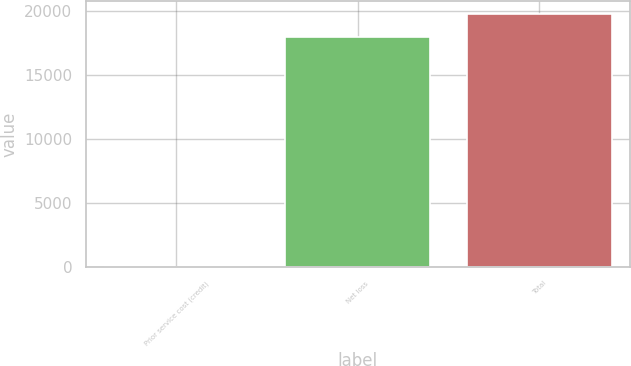Convert chart to OTSL. <chart><loc_0><loc_0><loc_500><loc_500><bar_chart><fcel>Prior service cost (credit)<fcel>Net loss<fcel>Total<nl><fcel>18<fcel>17986<fcel>19784.6<nl></chart> 